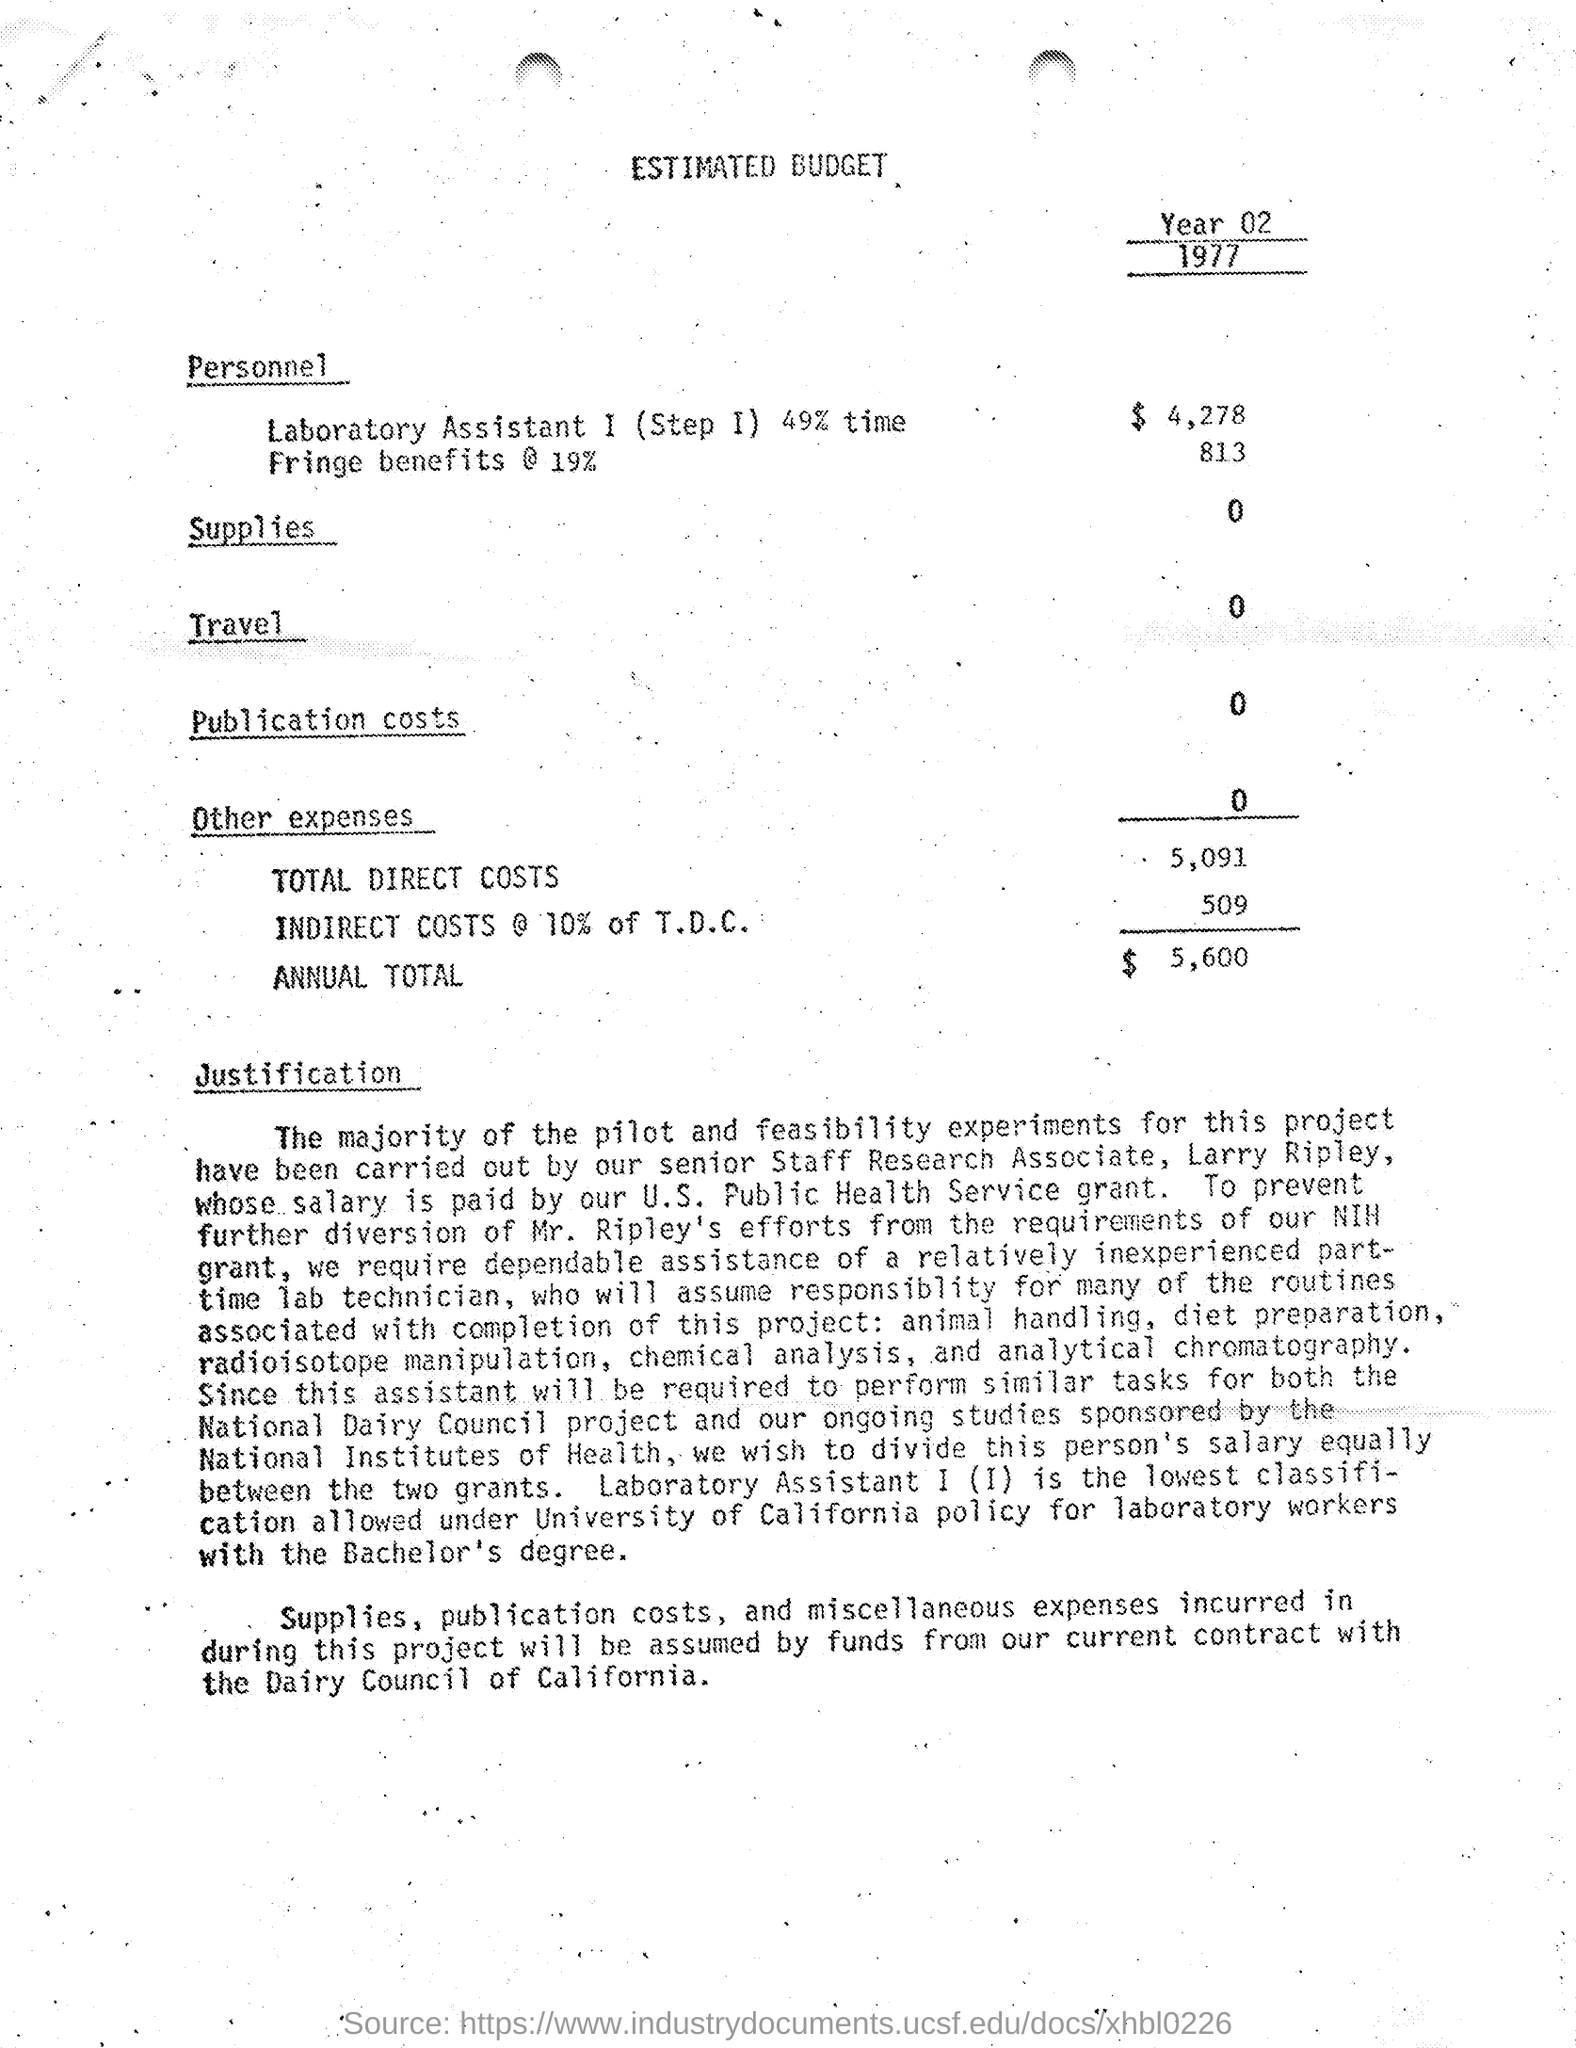What is the year of estimated budget ?
Provide a succinct answer. 1977. What is the amount of total direct costs mentioned in the given budget ?
Your answer should be very brief. 5,091. What is the amount of indirect costs mentioned in the given budget ?
Provide a succinct answer. 509. What is the amount of annual total mentioned in the given budget ?
Your answer should be very brief. $5,600. What is the amount of fringe benefits as mentioned in the given budget ?
Make the answer very short. 813. What is the amount given for laboratory assistant 1 mentioned in the estimated budget ?
Offer a terse response. $4,278. What is the amount given for travel in the given budget ?
Offer a very short reply. 0. What is the amount given for supplies in the estimated budget ?
Your response must be concise. 0. What is the amount of publication costs mentioned in the estimated budget ?
Give a very brief answer. 0. What is the amount of other expenses mentioned in the estimated budget ?
Your response must be concise. 0. 